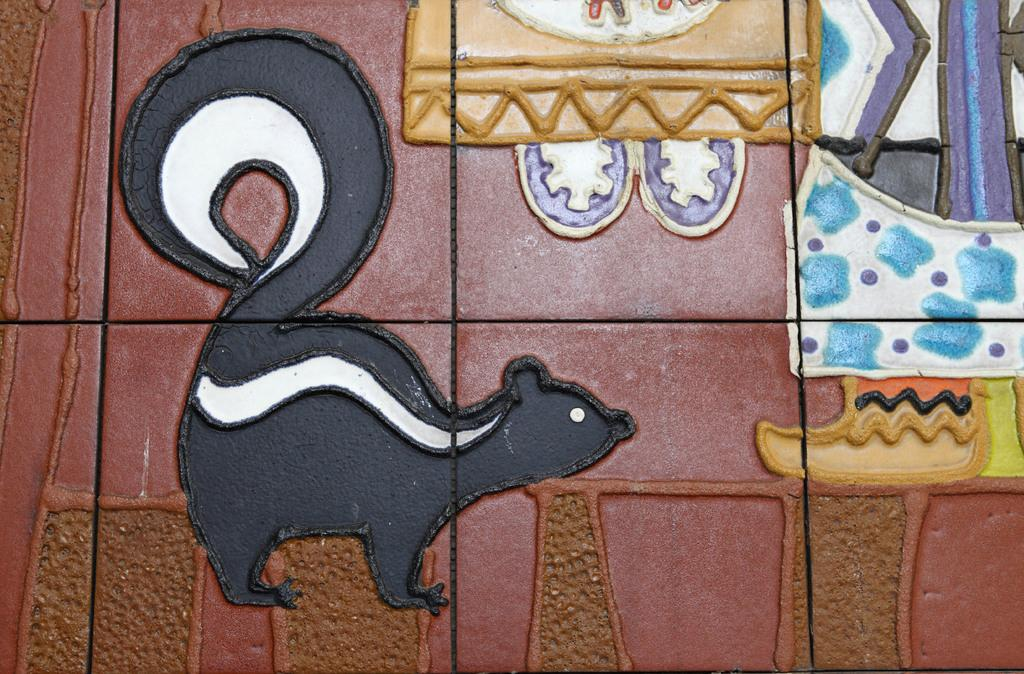What is depicted on the tiles in the image? There are paintings on the tiles in the image. What type of kitty is shown using a wrench in one of the paintings on the tiles? There is no kitty or wrench present in any of the paintings on the tiles in the image. 